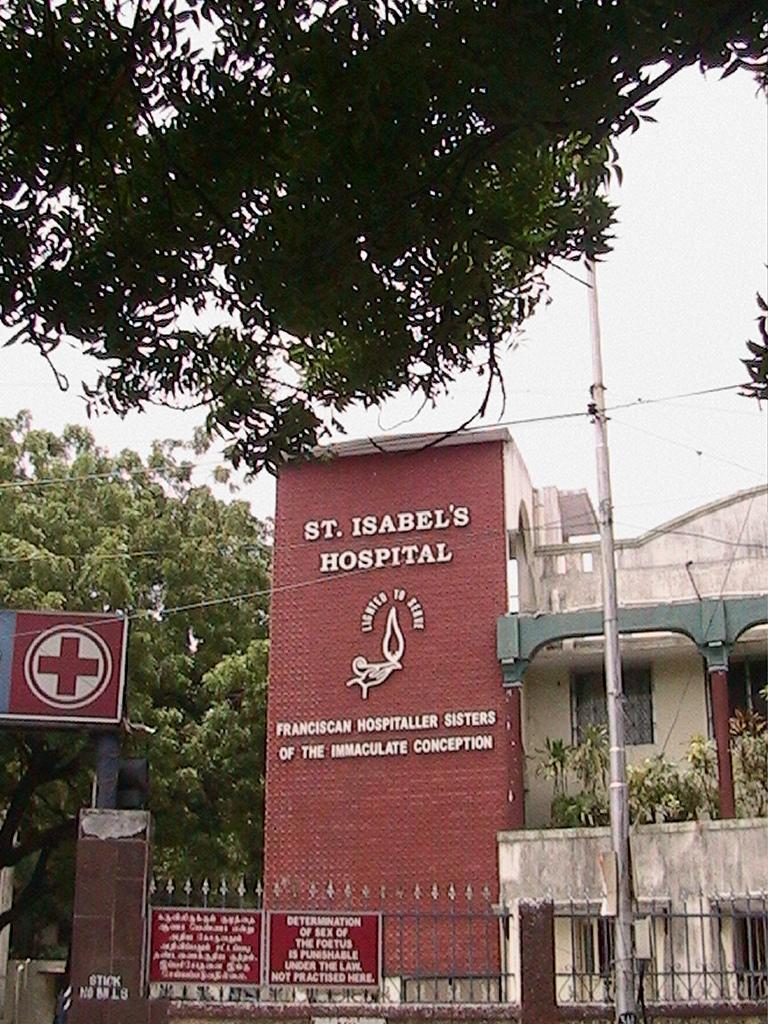Can you describe this image briefly? As we can see in the image there are buildings, plants, trees and fence. On the top there is a sky. 